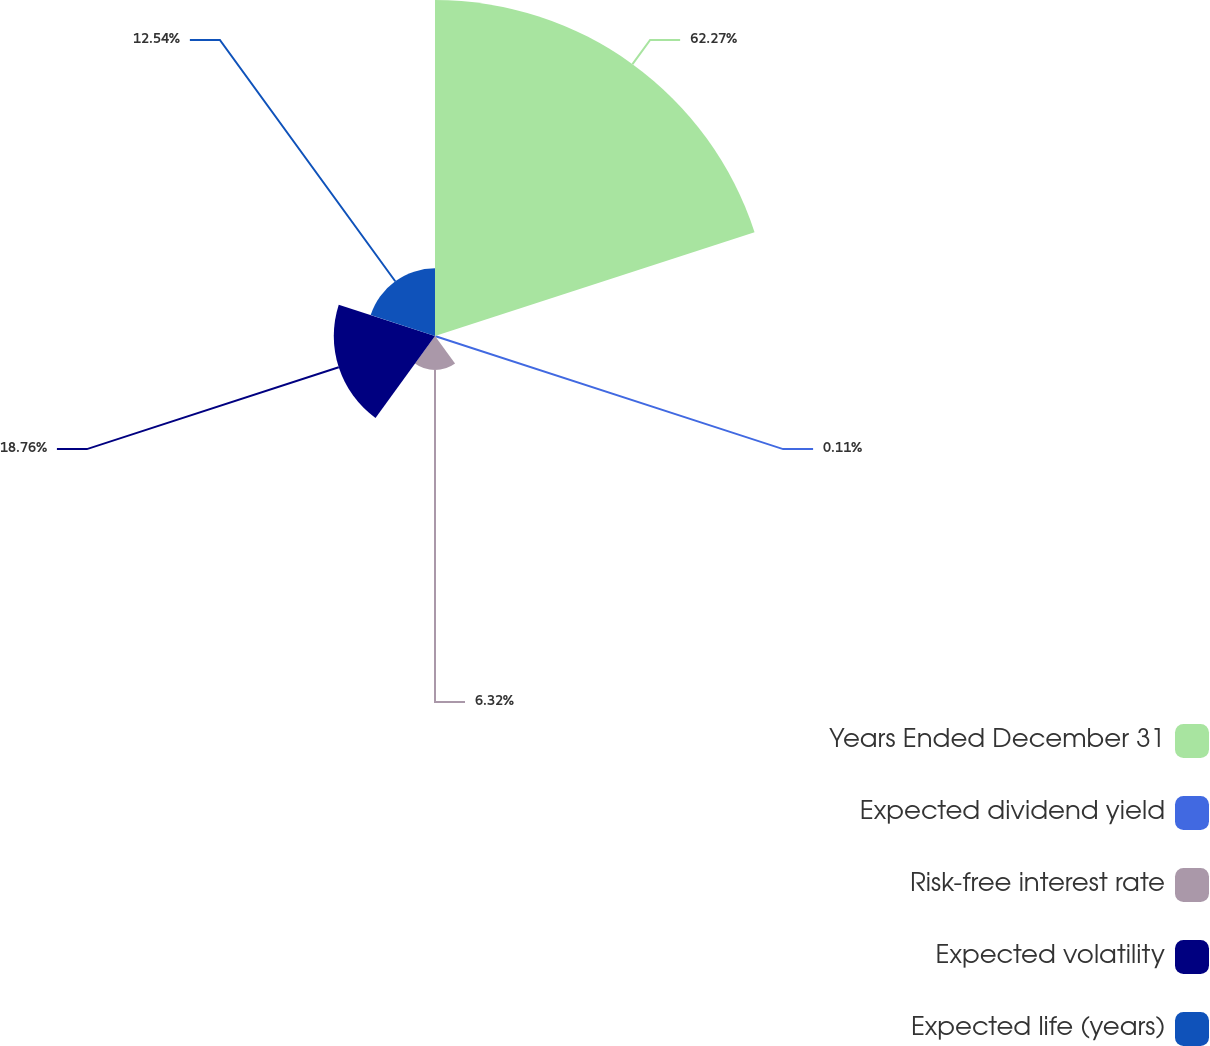Convert chart. <chart><loc_0><loc_0><loc_500><loc_500><pie_chart><fcel>Years Ended December 31<fcel>Expected dividend yield<fcel>Risk-free interest rate<fcel>Expected volatility<fcel>Expected life (years)<nl><fcel>62.28%<fcel>0.11%<fcel>6.32%<fcel>18.76%<fcel>12.54%<nl></chart> 